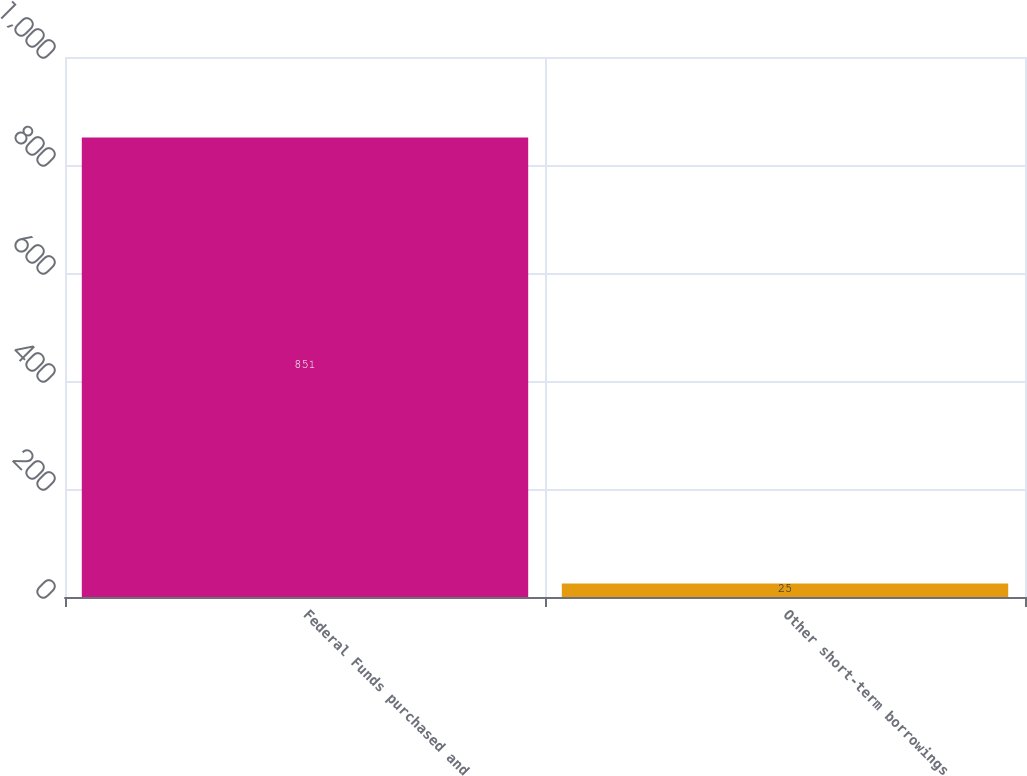<chart> <loc_0><loc_0><loc_500><loc_500><bar_chart><fcel>Federal Funds purchased and<fcel>Other short-term borrowings<nl><fcel>851<fcel>25<nl></chart> 